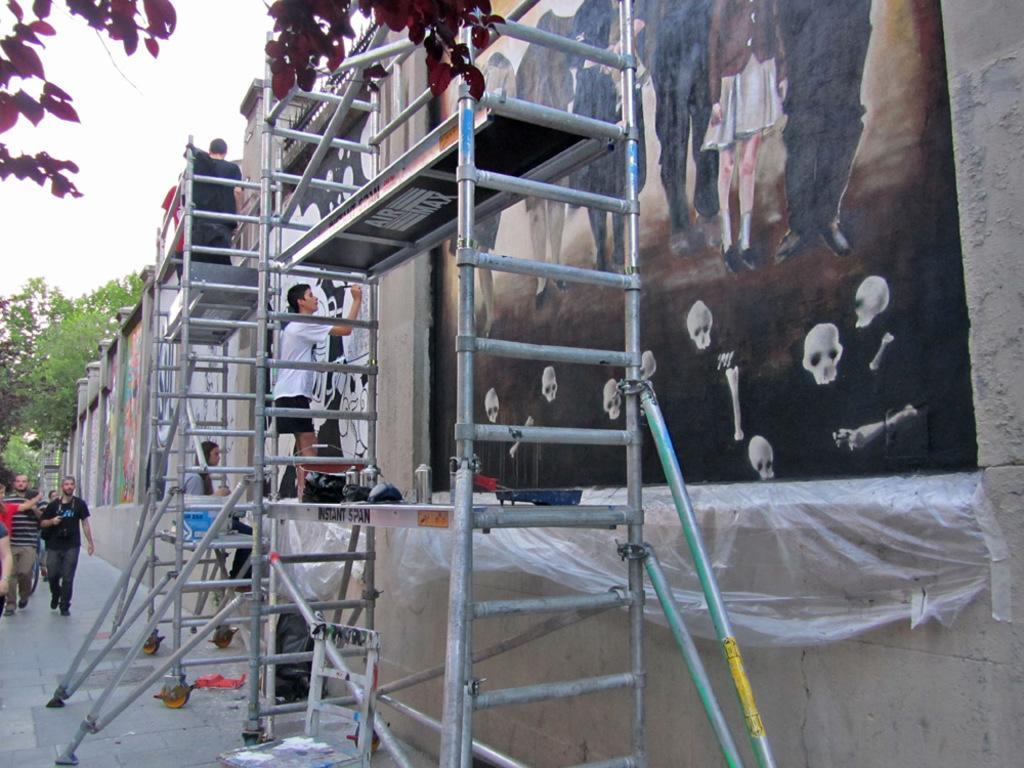Describe this image in one or two sentences. In this image we can see some pictures which are painted on the wall. We can also see a ladder with some metal poles and some people standing on that. We can also see some containers and objects on the stand. On the left side we can see some people standing, a group of trees and the sky. 